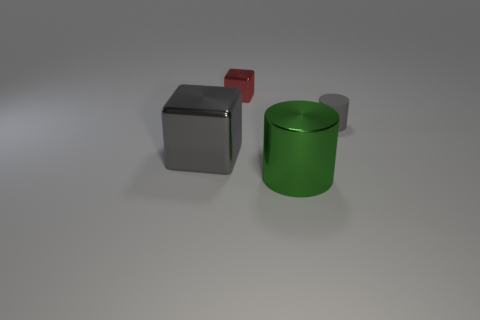Subtract all gray cylinders. How many cylinders are left? 1 Add 1 big gray shiny cubes. How many objects exist? 5 Subtract all brown cylinders. Subtract all green spheres. How many cylinders are left? 2 Subtract all cyan balls. How many purple cubes are left? 0 Subtract all small gray objects. Subtract all cyan cylinders. How many objects are left? 3 Add 1 big metallic objects. How many big metallic objects are left? 3 Add 3 tiny green matte objects. How many tiny green matte objects exist? 3 Subtract 0 yellow cylinders. How many objects are left? 4 Subtract 1 cylinders. How many cylinders are left? 1 